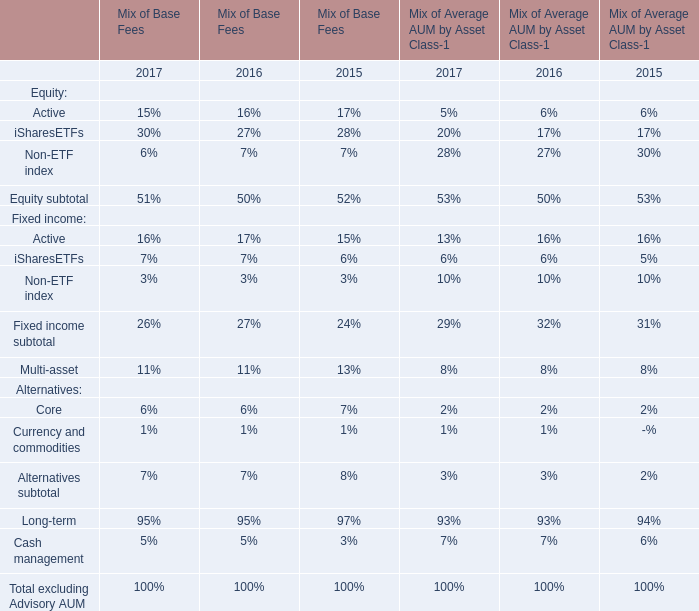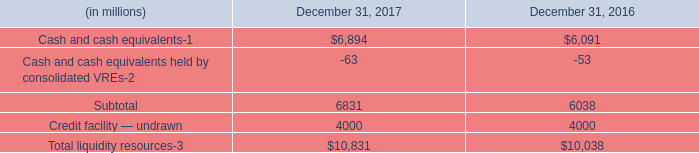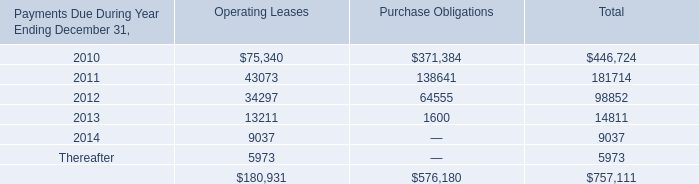what is the growth rate in the balance of cash and cash equivalents in 2017? 
Computations: ((6894 - 6091) / 6091)
Answer: 0.13183. 